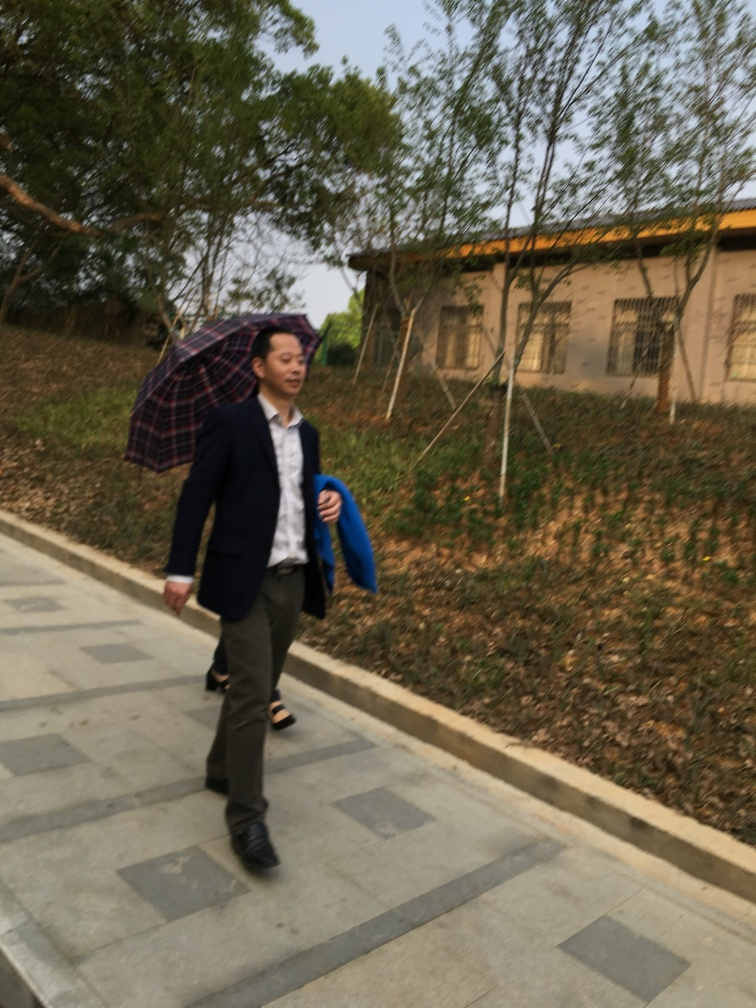How is the main subject in this photo?
A. Blurry with no texture details
B. Invisible
C. Slightly blurry but retains most texture details The main subject in the photo is slightly blurry but retains most texture details. Although there is some motion blur evident, which indicates movement, features such as the individual's clothing and facial expression are still discernible. 